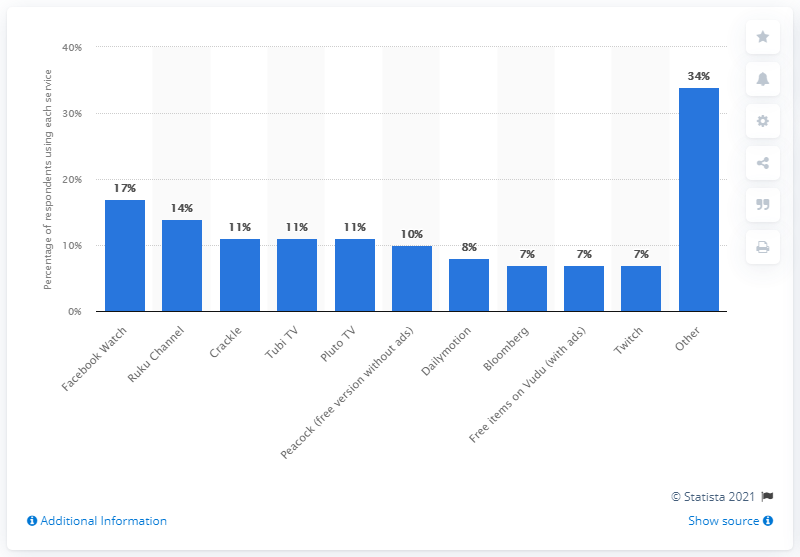Mention a couple of crucial points in this snapshot. In 2020, the most popular AVoD service in North America was Facebook Watch. 